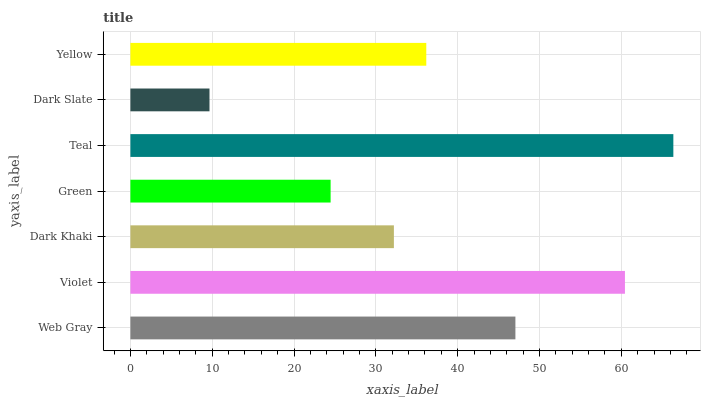Is Dark Slate the minimum?
Answer yes or no. Yes. Is Teal the maximum?
Answer yes or no. Yes. Is Violet the minimum?
Answer yes or no. No. Is Violet the maximum?
Answer yes or no. No. Is Violet greater than Web Gray?
Answer yes or no. Yes. Is Web Gray less than Violet?
Answer yes or no. Yes. Is Web Gray greater than Violet?
Answer yes or no. No. Is Violet less than Web Gray?
Answer yes or no. No. Is Yellow the high median?
Answer yes or no. Yes. Is Yellow the low median?
Answer yes or no. Yes. Is Green the high median?
Answer yes or no. No. Is Teal the low median?
Answer yes or no. No. 